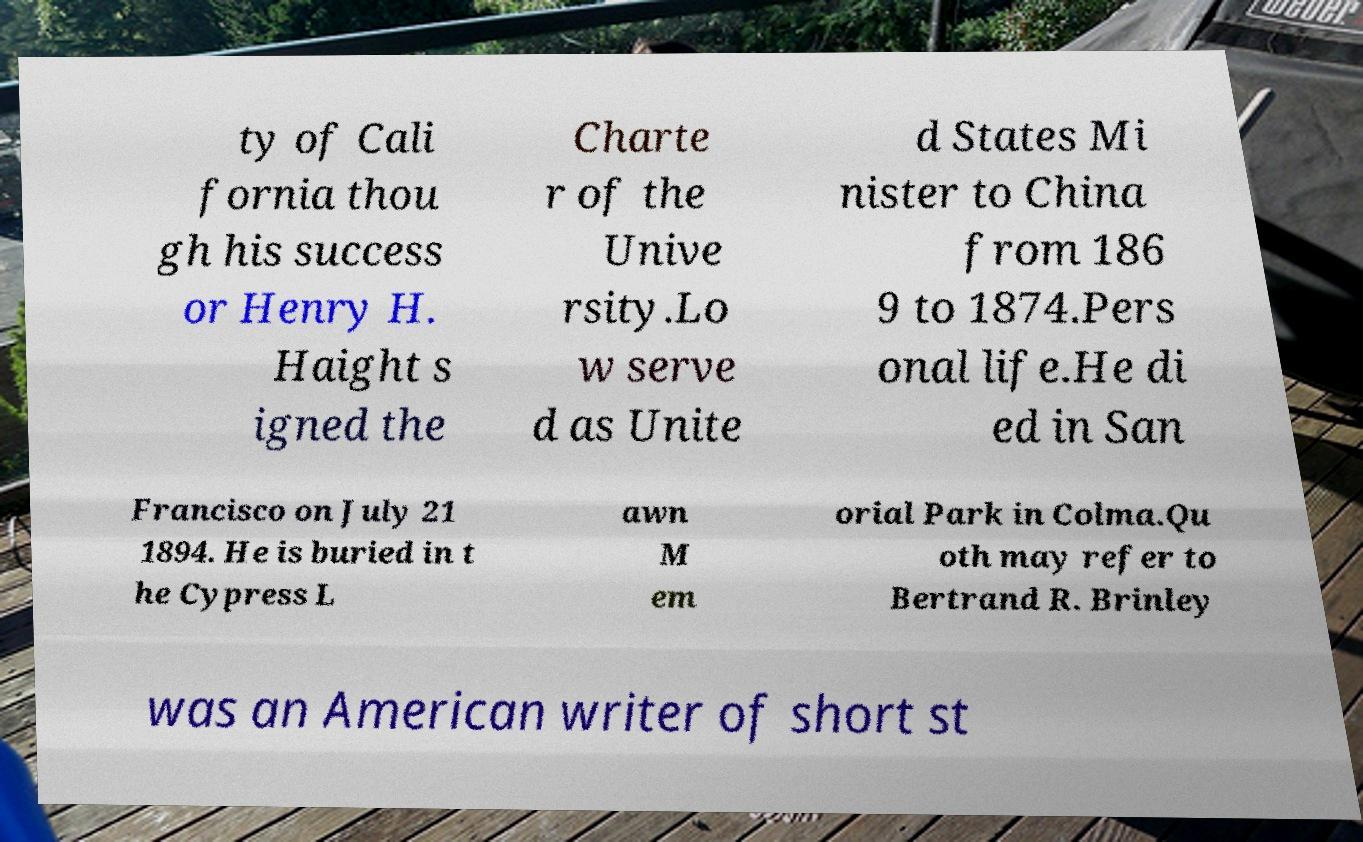Can you read and provide the text displayed in the image?This photo seems to have some interesting text. Can you extract and type it out for me? ty of Cali fornia thou gh his success or Henry H. Haight s igned the Charte r of the Unive rsity.Lo w serve d as Unite d States Mi nister to China from 186 9 to 1874.Pers onal life.He di ed in San Francisco on July 21 1894. He is buried in t he Cypress L awn M em orial Park in Colma.Qu oth may refer to Bertrand R. Brinley was an American writer of short st 